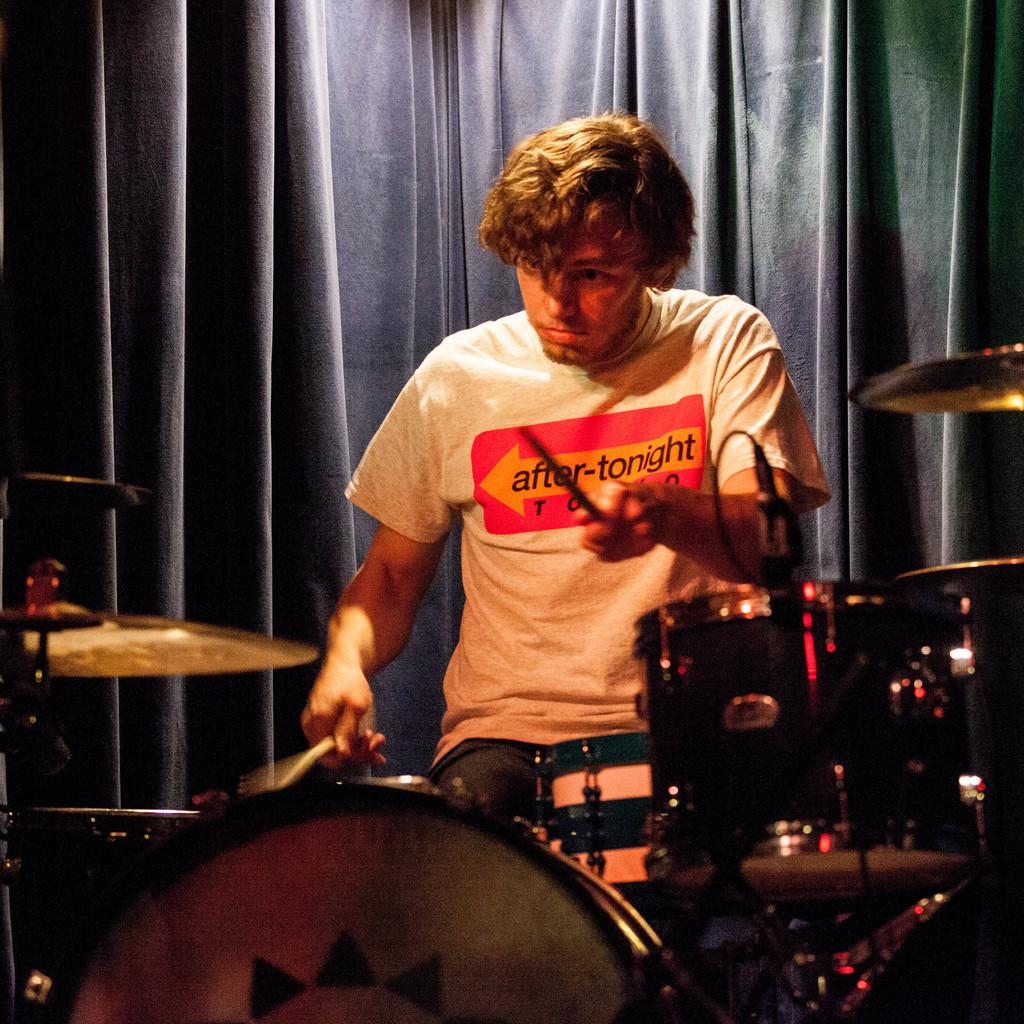What is the man in the image doing? The man is playing the drums. What is the man holding in the image? The man is holding drumsticks. Can you describe any background elements in the image? There is a curtain visible in the image. What type of committee is meeting behind the curtain in the image? There is no committee meeting behind the curtain in the image; it is simply a background element. 